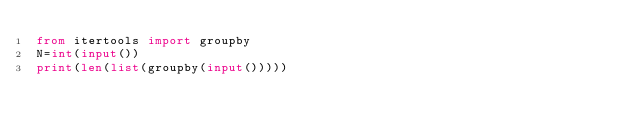<code> <loc_0><loc_0><loc_500><loc_500><_Python_>from itertools import groupby
N=int(input())
print(len(list(groupby(input()))))
</code> 